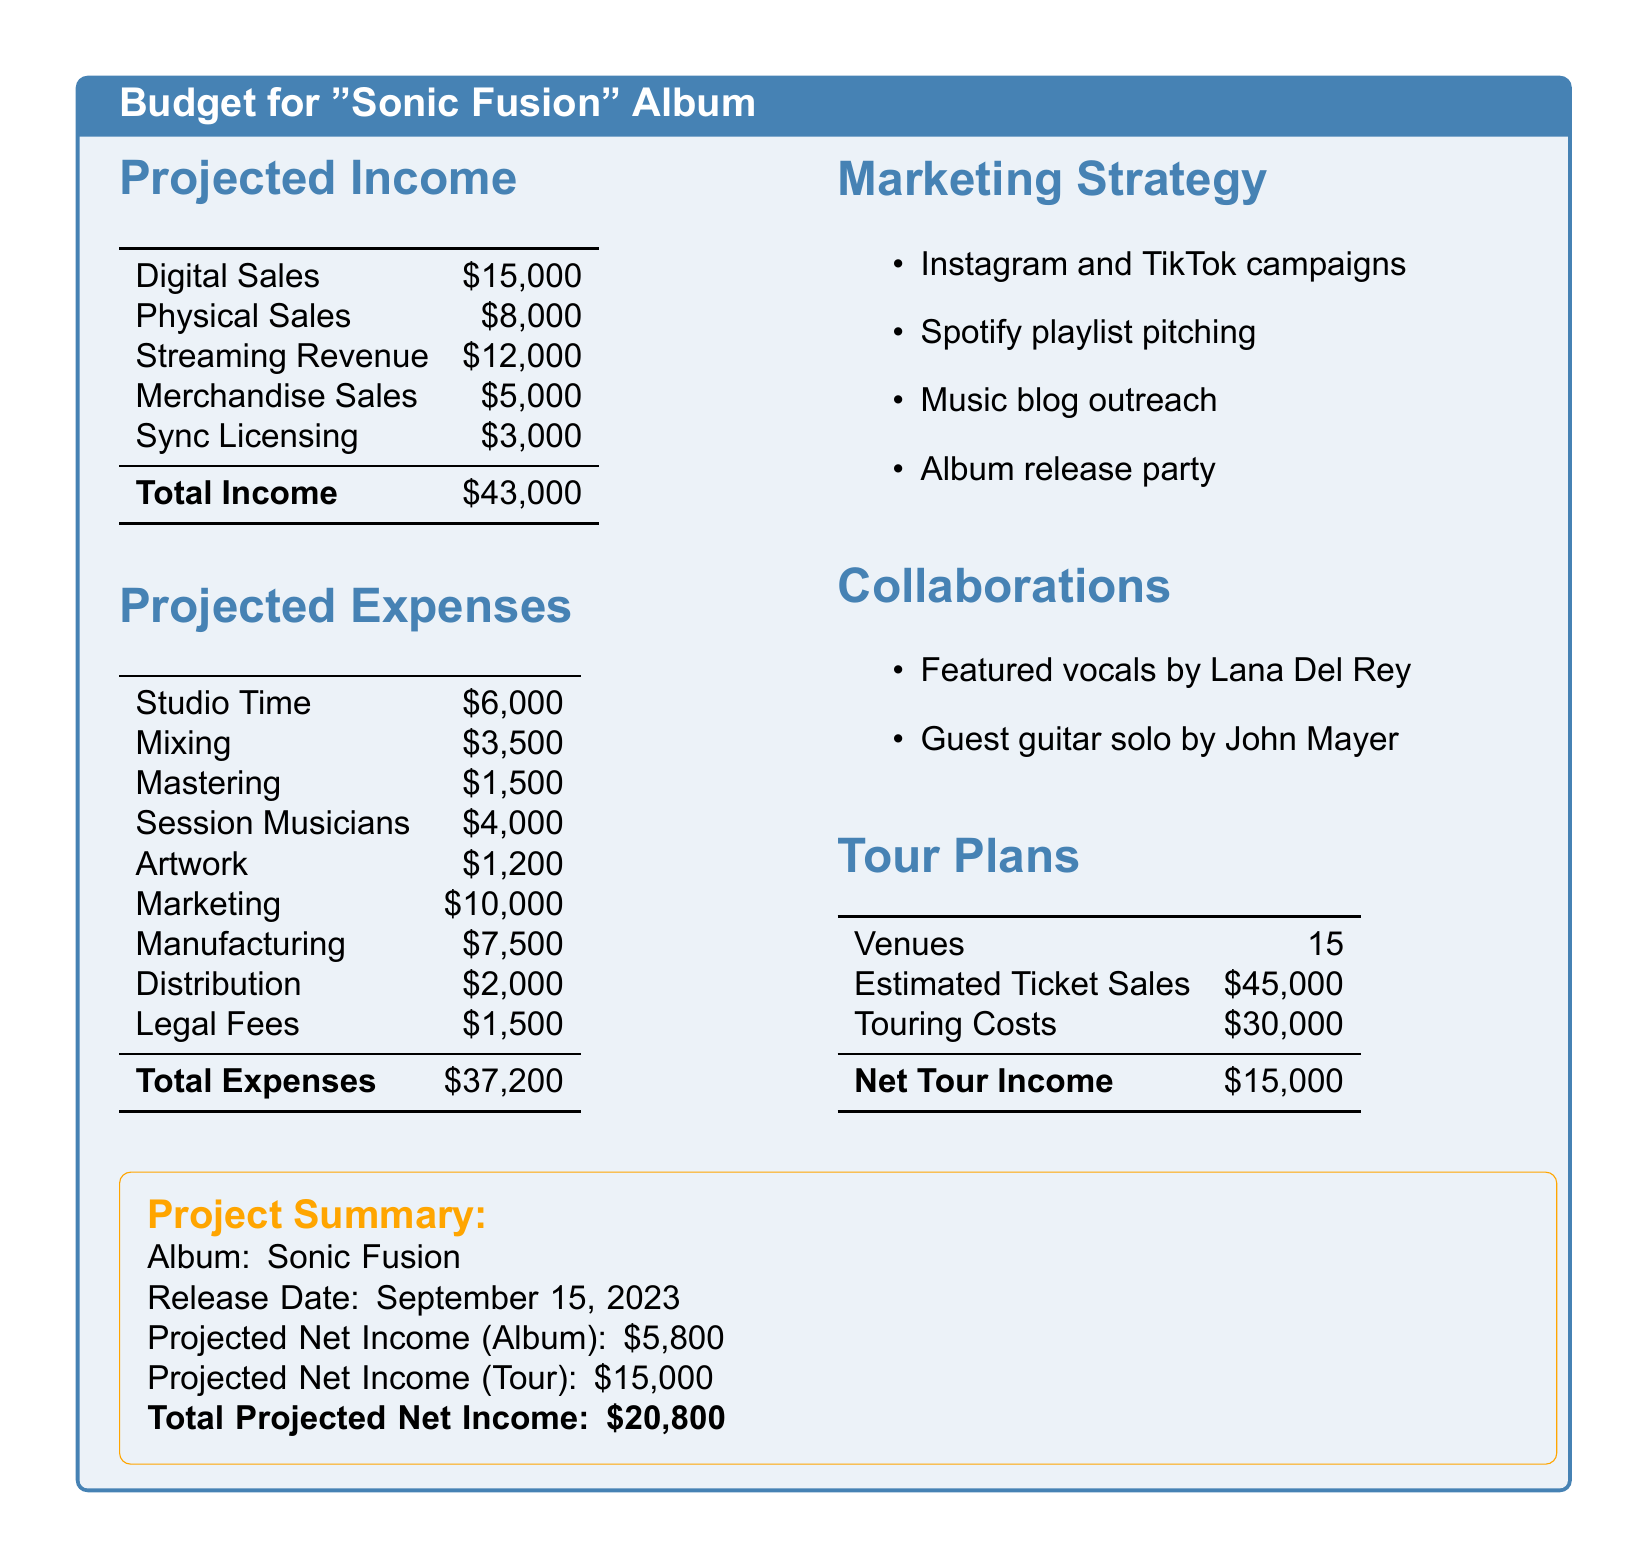What is the total projected income? The total projected income is the sum of all income sources listed in the document, which is $15,000 + $8,000 + $12,000 + $5,000 + $3,000 = $43,000.
Answer: $43,000 What is the total projected expenses? The total projected expenses is the sum of all expenses listed in the document, which is $6,000 + $3,500 + $1,500 + $4,000 + $1,200 + $10,000 + $7,500 + $2,000 + $1,500 = $37,200.
Answer: $37,200 What is the projected net income from the album? The projected net income from the album is calculated by subtracting total expenses from total income, which is $43,000 - $37,200 = $5,800.
Answer: $5,800 How many venues are planned for the tour? The document states that there are 15 venues planned for the tour.
Answer: 15 What is the estimated ticket sales for the tour? The document mentions that the estimated ticket sales for the tour are $45,000.
Answer: $45,000 What is the marketing budget? The marketing budget is listed as $10,000 in the document.
Answer: $10,000 Who is featured on the album? The document mentions featured vocals by Lana Del Rey as part of the album collaborations.
Answer: Lana Del Rey What is the release date of the album? According to the document, the album is set to release on September 15, 2023.
Answer: September 15, 2023 What are the total projected net incomes combined from the album and tour? The document states the total projected net income from the album is $5,800 and $15,000 from the tour, totaling $20,800.
Answer: $20,800 